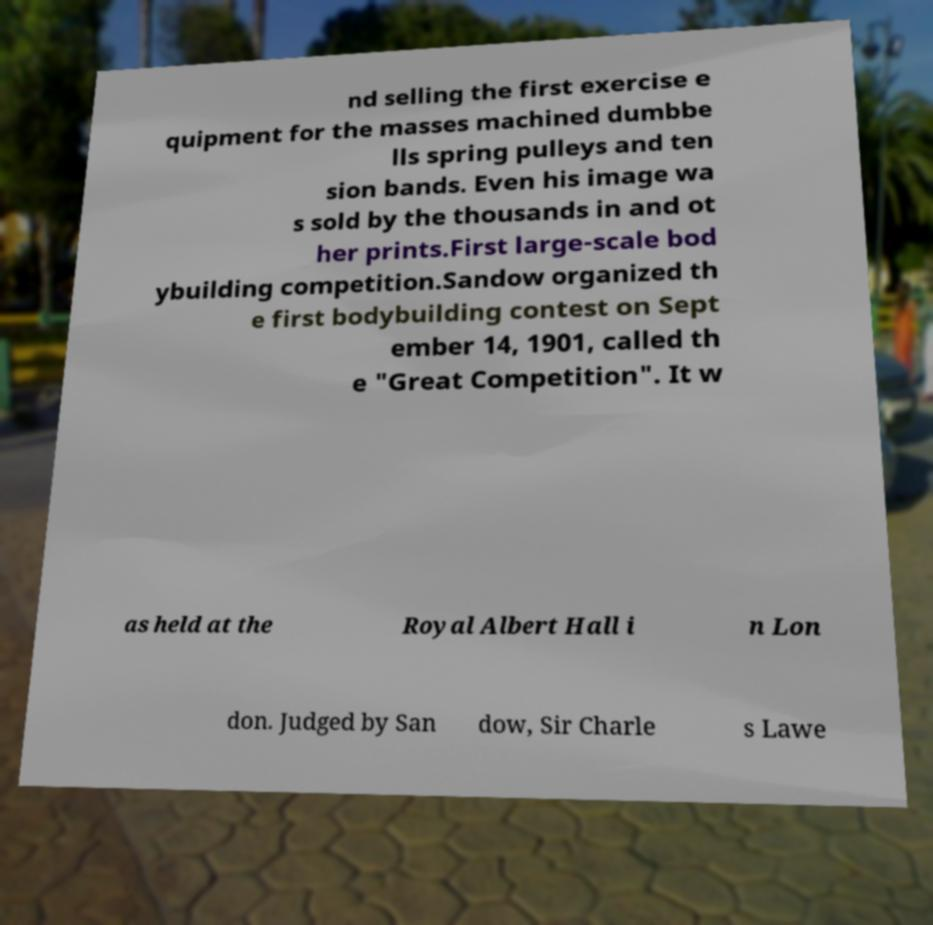There's text embedded in this image that I need extracted. Can you transcribe it verbatim? nd selling the first exercise e quipment for the masses machined dumbbe lls spring pulleys and ten sion bands. Even his image wa s sold by the thousands in and ot her prints.First large-scale bod ybuilding competition.Sandow organized th e first bodybuilding contest on Sept ember 14, 1901, called th e "Great Competition". It w as held at the Royal Albert Hall i n Lon don. Judged by San dow, Sir Charle s Lawe 